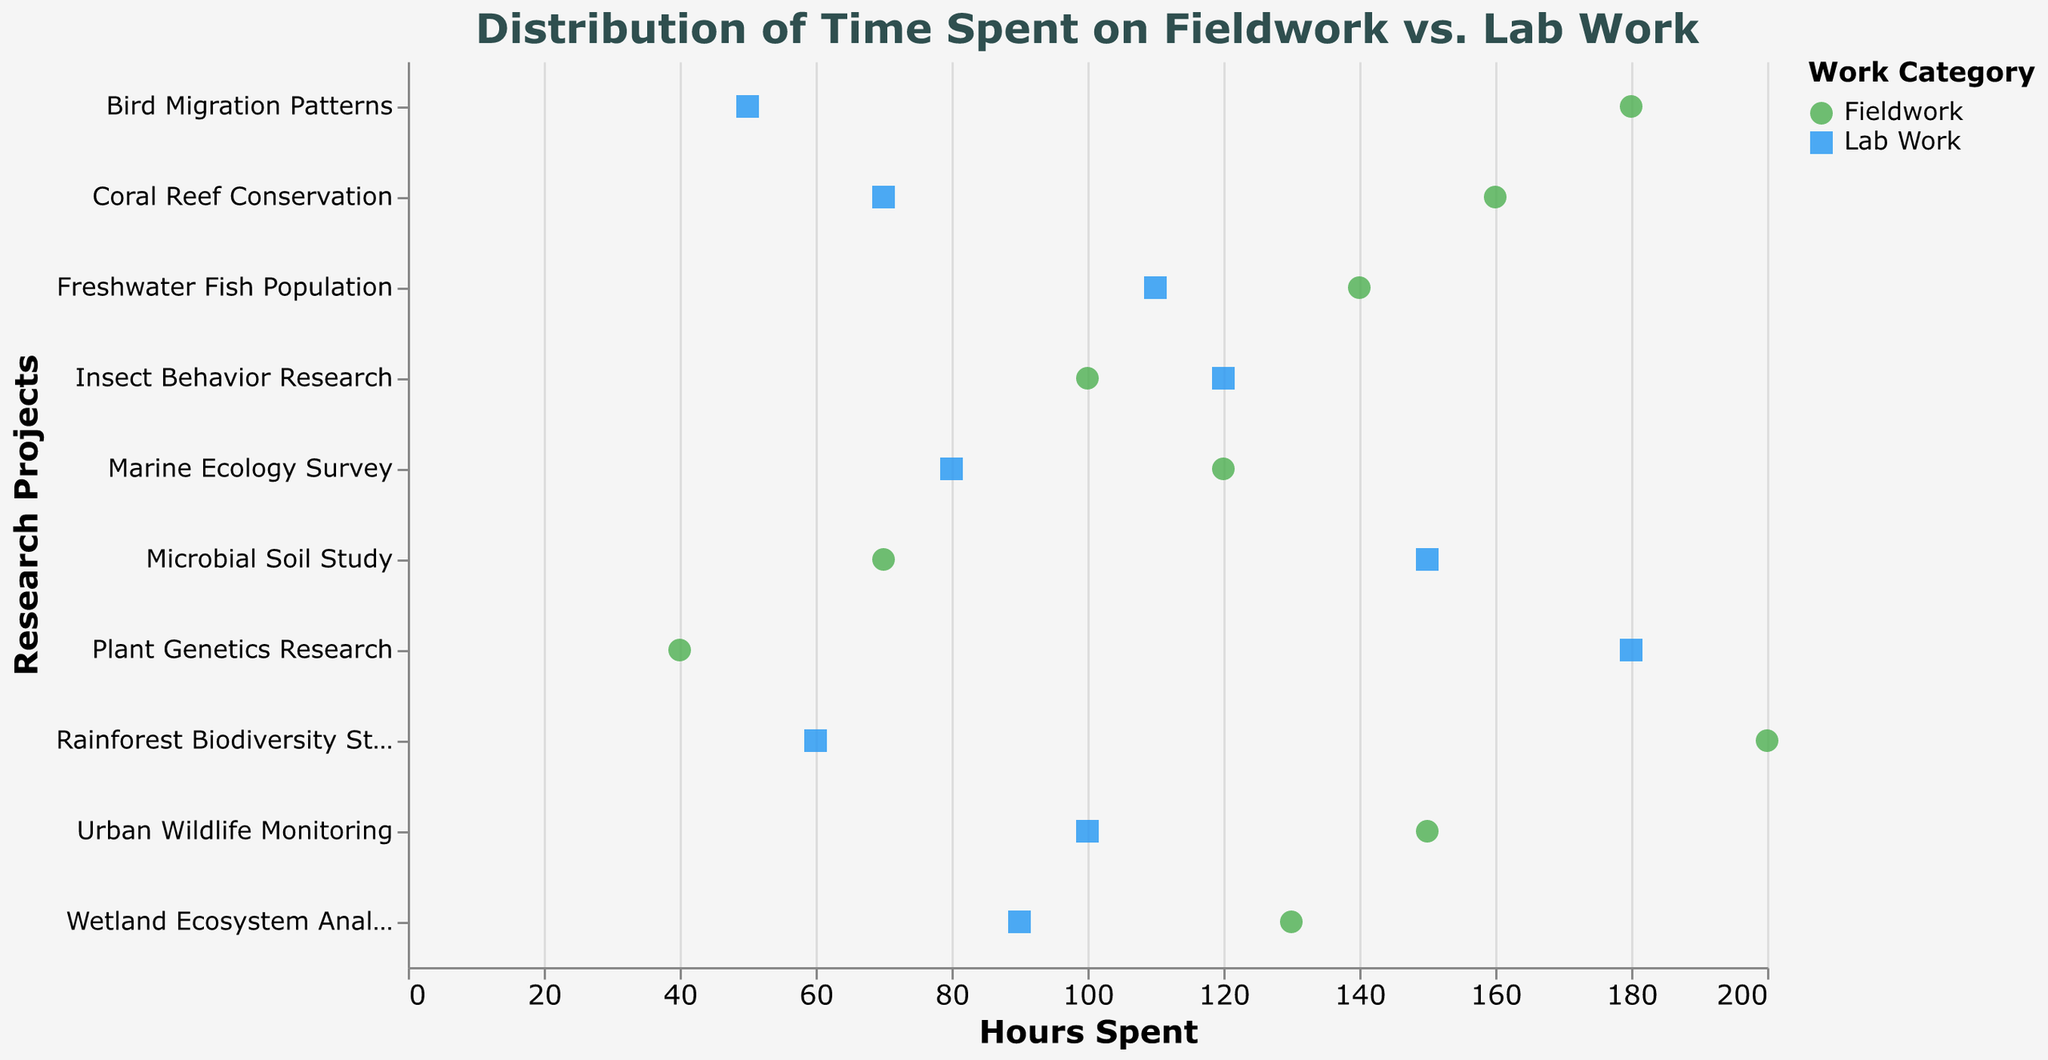What's the title of the plot? The title is usually displayed at the top of the plot to explain what the figure represents. Here, it reads "Distribution of Time Spent on Fieldwork vs. Lab Work".
Answer: Distribution of Time Spent on Fieldwork vs. Lab Work How many projects have more hours spent on fieldwork compared to lab work? To determine this, we compare the hours spent on fieldwork and lab work for each project and count how many of them have more hours on fieldwork.
Answer: 7 Which project has the highest total hours spent combining both fieldwork and lab work? First, add together the hours spent on fieldwork and lab work for each project. Then, identify the project with the highest total. For instance, Rainforest Biodiversity Study has 200(FW) + 60(LW) = 260 hours.
Answer: Rainforest Biodiversity Study Between "Urban Wildlife Monitoring" and "Microbial Soil Study", which project has more hours spent on lab work? By comparing the lab work hours of both projects, we see that "Urban Wildlife Monitoring" has 100 hours, while "Microbial Soil Study" has 150 hours.
Answer: Microbial Soil Study What's the difference in fieldwork hours between "Rainforest Biodiversity Study" and "Freshwater Fish Population"? The hours spent on fieldwork for the two projects are 200 and 140 respectively. Subtracting the smaller value from the larger gives 200 - 140 = 60.
Answer: 60 On average, how many hours are spent per project on lab work? To calculate the average, sum all the hours spent on lab work across all projects and divide by the number of projects. The total is 80+60+100+180+70+90+150+50+110+120 = 1010. Dividing this by 10 projects gives 1010/10.
Answer: 101 Which category, fieldwork or lab work, has more variability in hours? Variability can be judged using the spread of hours within each category. Lab work's hours range from 50 to 180, a spread of 130. Fieldwork ranges from 40 to 200, a spread of 160.
Answer: Fieldwork What is the shape used to represent lab work on the plot? The plot designates shapes based on the category, with lab work represented by squares.
Answer: Square 